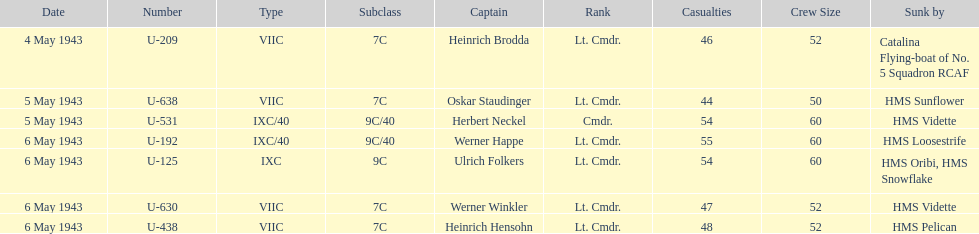Aside from oskar staudinger what was the name of the other captain of the u-boat loast on may 5? Herbert Neckel. 